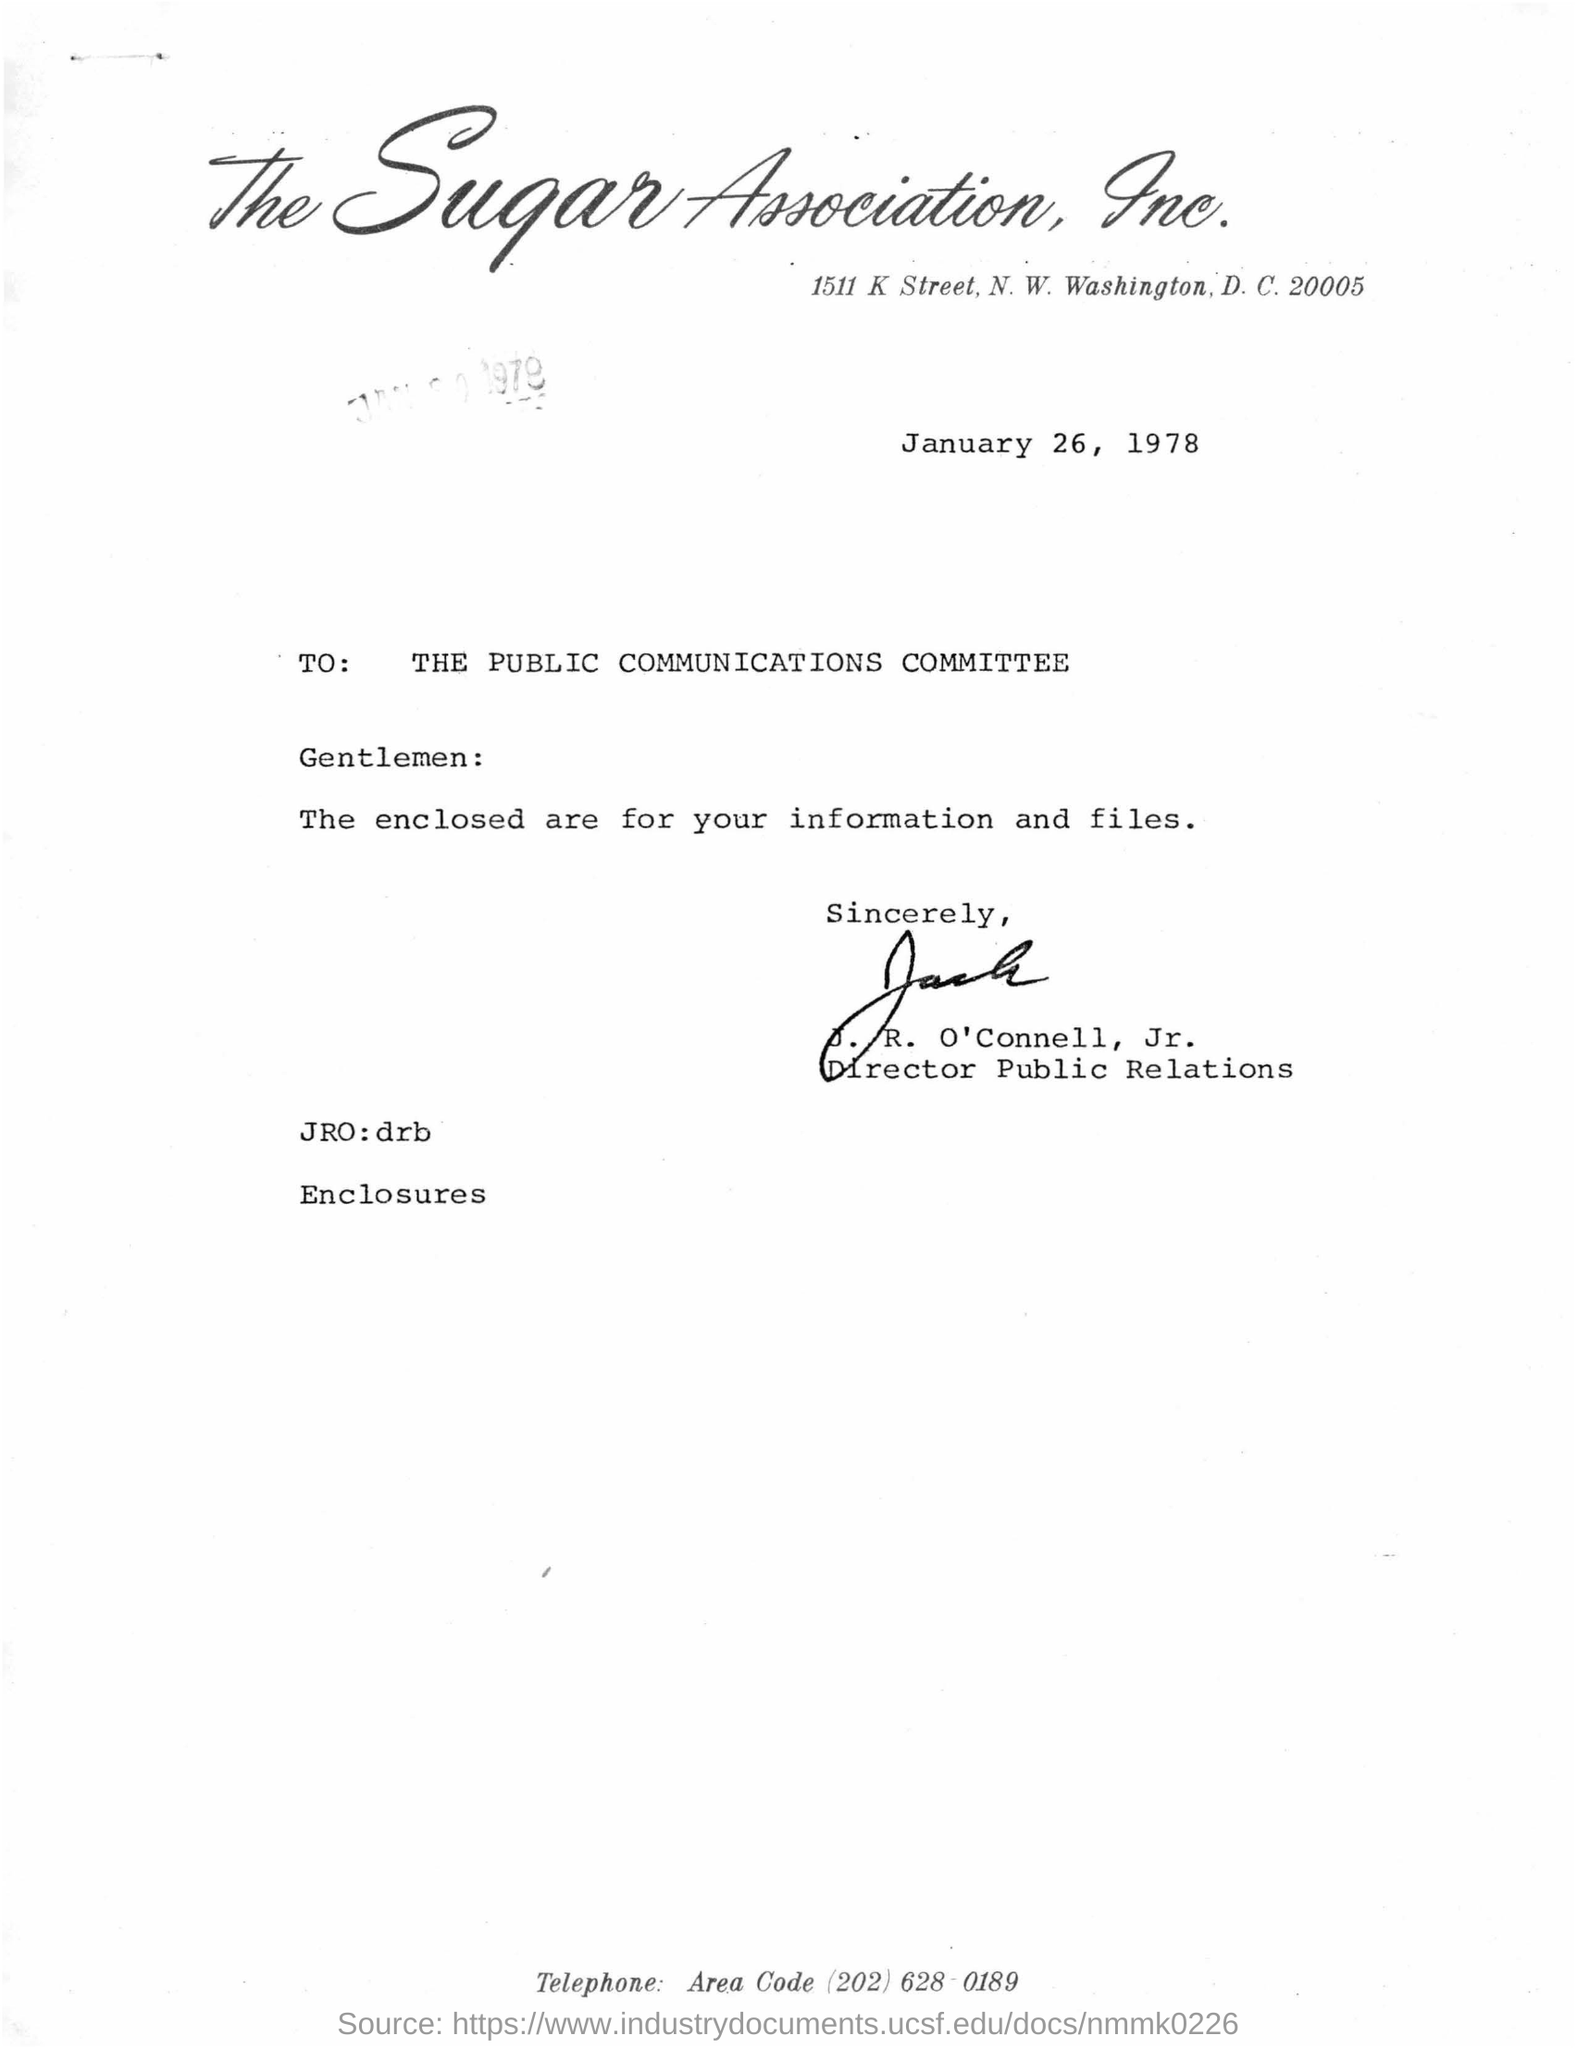What is the date mentioned in the document ?
Offer a very short reply. January 26, 1978. 